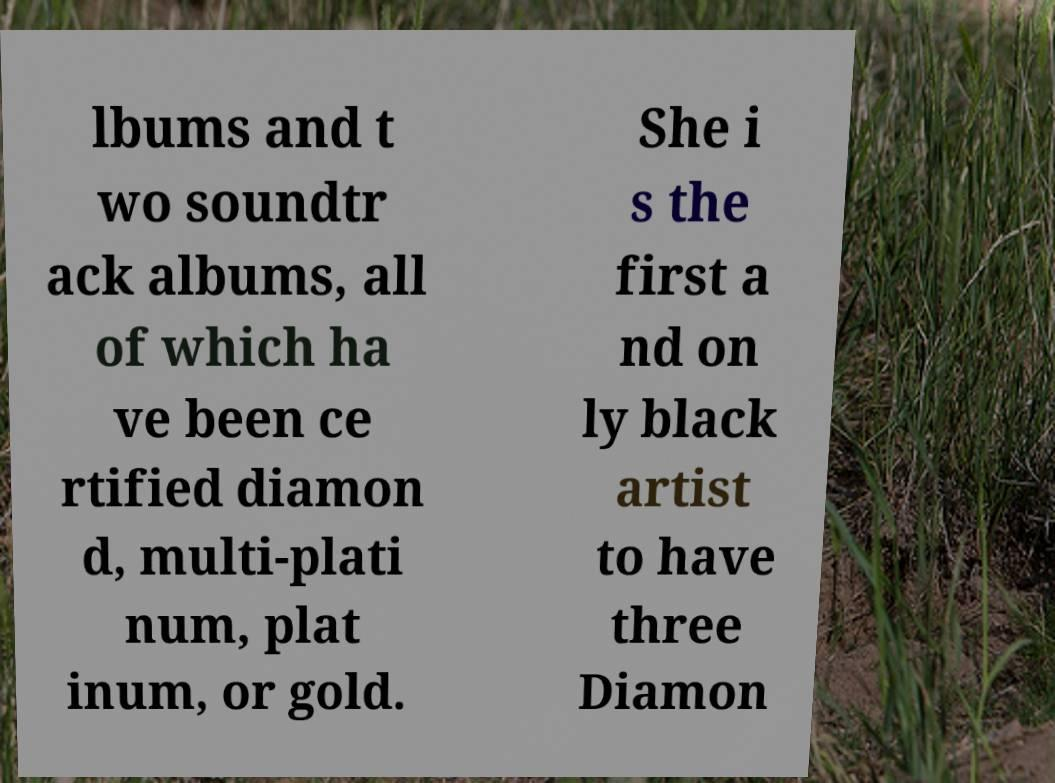Please read and relay the text visible in this image. What does it say? lbums and t wo soundtr ack albums, all of which ha ve been ce rtified diamon d, multi-plati num, plat inum, or gold. She i s the first a nd on ly black artist to have three Diamon 